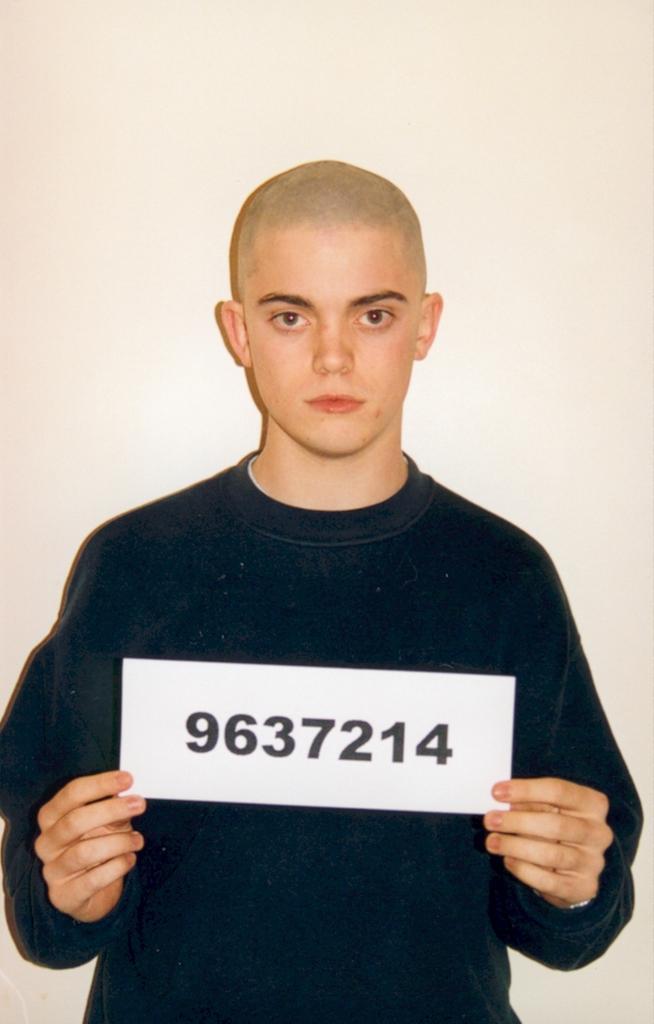Please provide a concise description of this image. In this image we can see a boy who is wearing black color t-shirt and holding paper in his hand. And on paper some number is written. Behind the boy white color wall is there. 